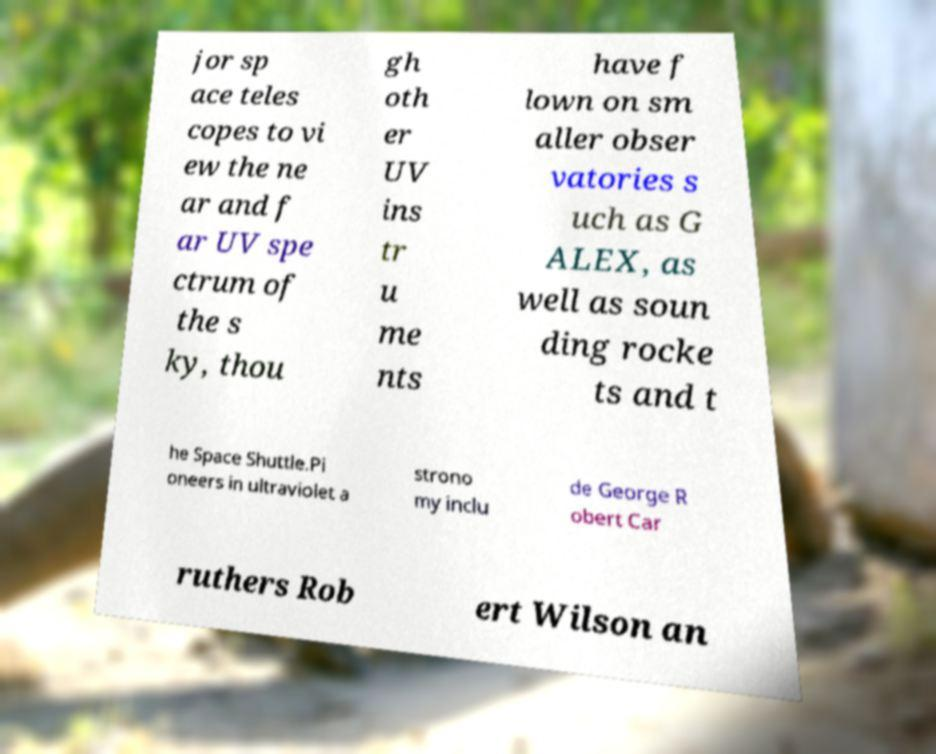For documentation purposes, I need the text within this image transcribed. Could you provide that? jor sp ace teles copes to vi ew the ne ar and f ar UV spe ctrum of the s ky, thou gh oth er UV ins tr u me nts have f lown on sm aller obser vatories s uch as G ALEX, as well as soun ding rocke ts and t he Space Shuttle.Pi oneers in ultraviolet a strono my inclu de George R obert Car ruthers Rob ert Wilson an 